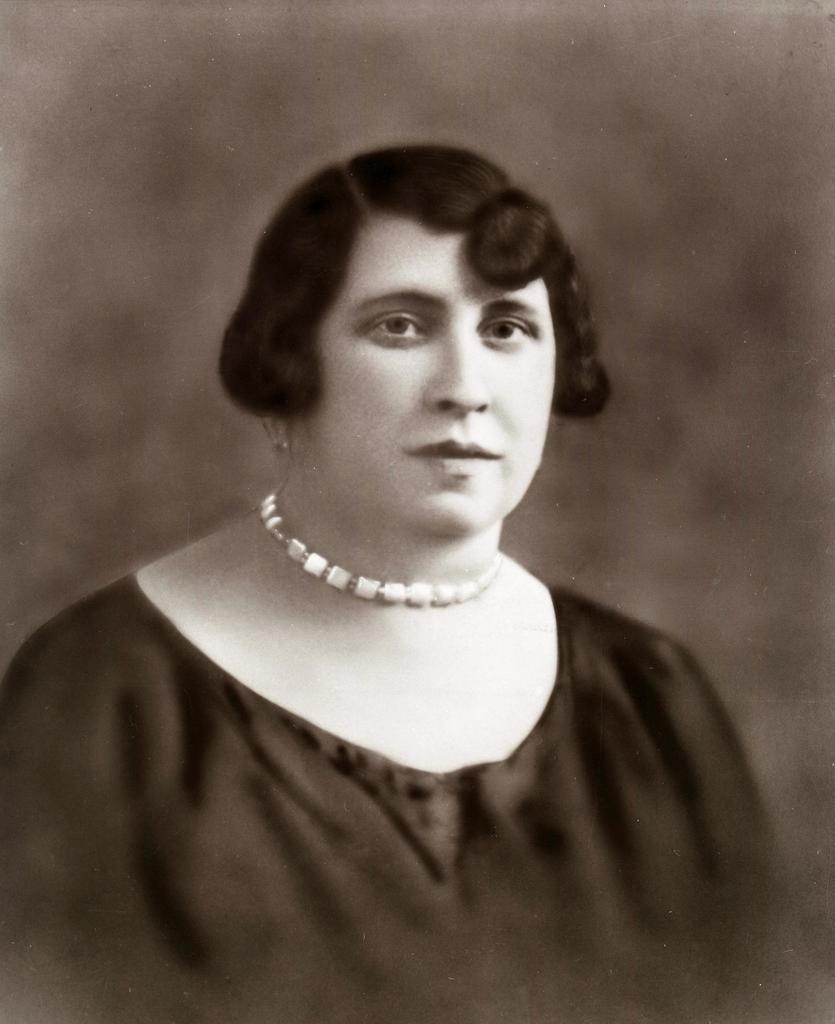In one or two sentences, can you explain what this image depicts? In this image we can see a lady, there is a necklace around her neck, the background is blurred, and the picture is taken in black and white mode. 